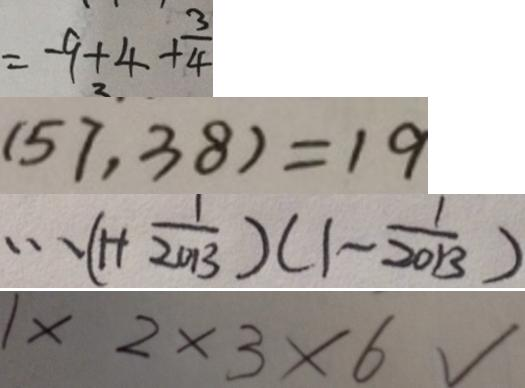<formula> <loc_0><loc_0><loc_500><loc_500>= - 9 + 4 + \frac { 3 } { 4 } 
 ( 5 7 , 3 8 ) = 1 9 
 \cdots ( 1 + \frac { 1 } { 2 0 1 3 } ) ( 1 - \frac { 1 } { 2 0 1 3 } ) 
 1 \times 2 \times 3 \times 6 √</formula> 